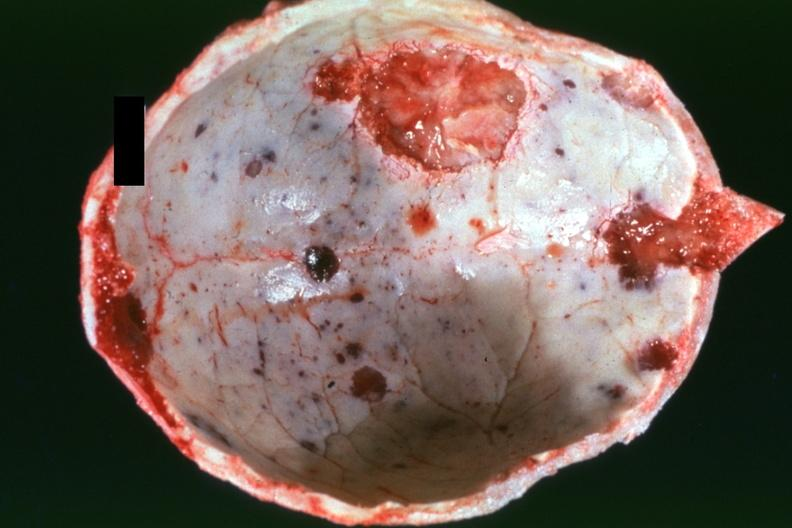what does this image show?
Answer the question using a single word or phrase. Dr garcia tumors b5 